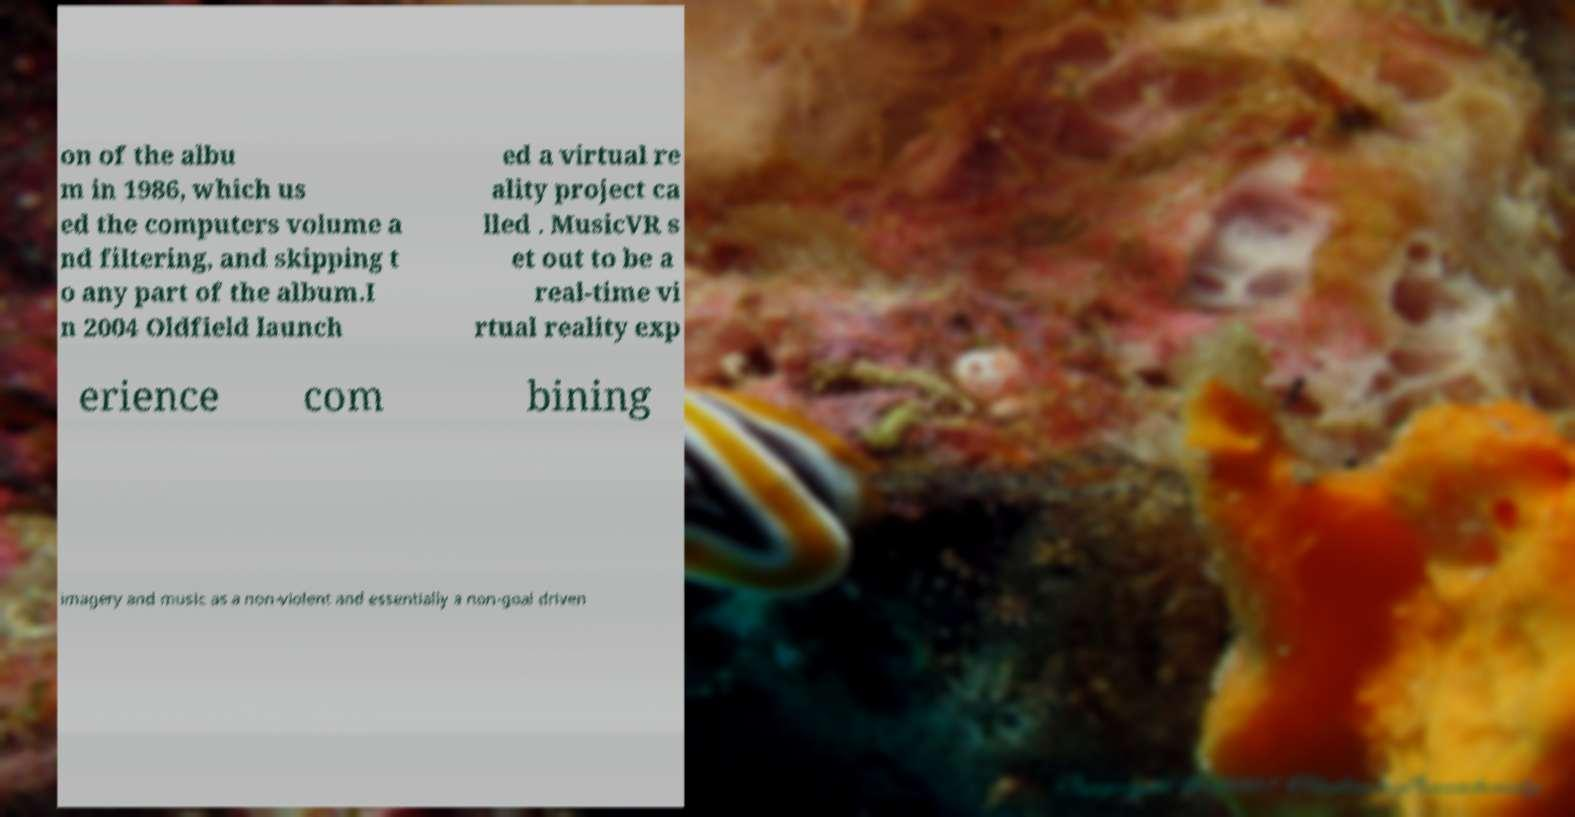There's text embedded in this image that I need extracted. Can you transcribe it verbatim? on of the albu m in 1986, which us ed the computers volume a nd filtering, and skipping t o any part of the album.I n 2004 Oldfield launch ed a virtual re ality project ca lled . MusicVR s et out to be a real-time vi rtual reality exp erience com bining imagery and music as a non-violent and essentially a non-goal driven 